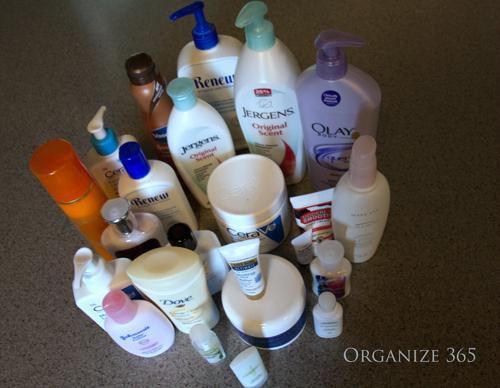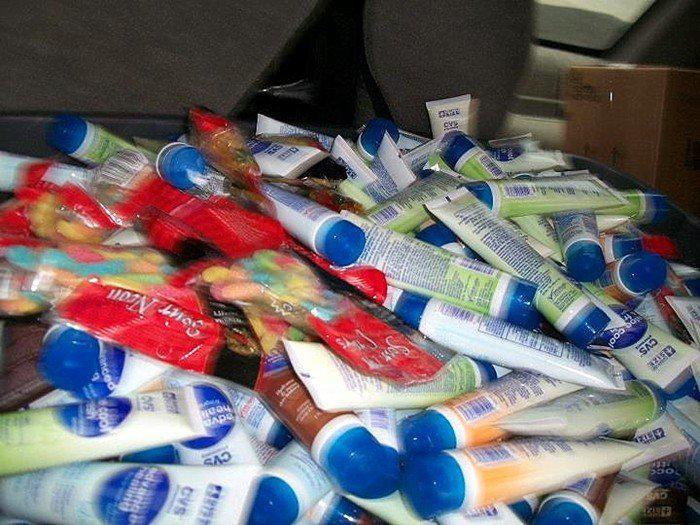The first image is the image on the left, the second image is the image on the right. Considering the images on both sides, is "The bottles in the image on the left are stacked in a tiered display." valid? Answer yes or no. No. 